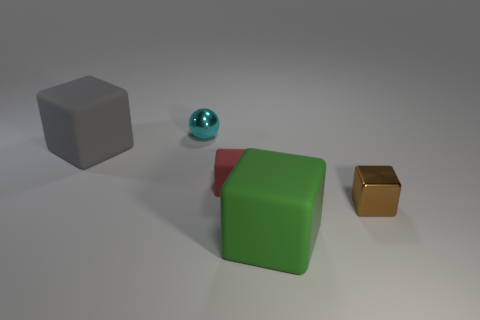Subtract all cyan cubes. Subtract all purple cylinders. How many cubes are left? 4 Add 4 gray things. How many objects exist? 9 Subtract all spheres. How many objects are left? 4 Add 2 large gray rubber things. How many large gray rubber things exist? 3 Subtract 0 purple blocks. How many objects are left? 5 Subtract all large gray rubber objects. Subtract all metal spheres. How many objects are left? 3 Add 5 green things. How many green things are left? 6 